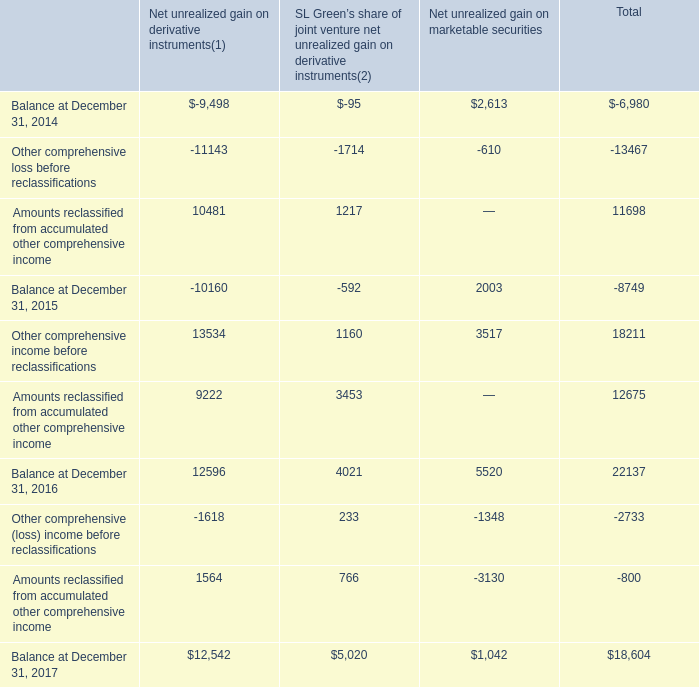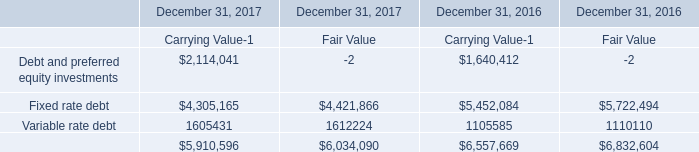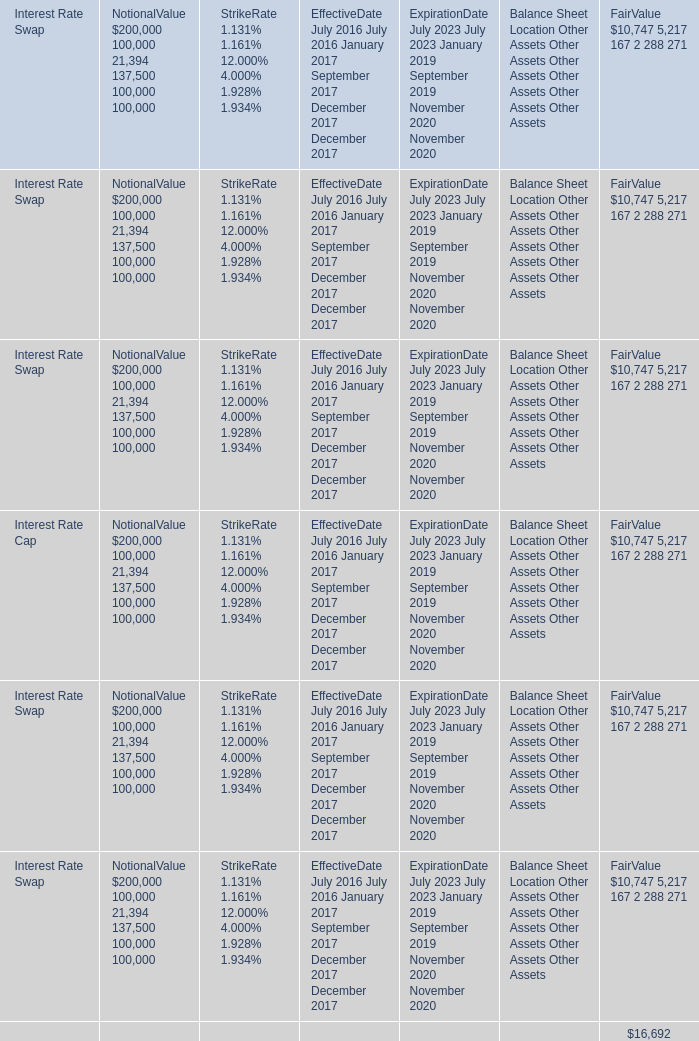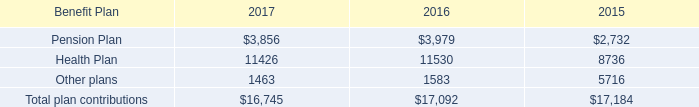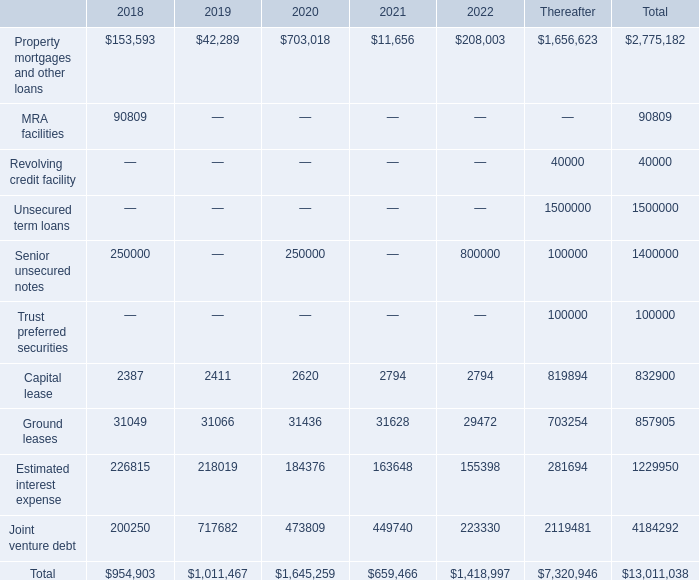What is the growing rate of Other comprehensive (loss) income before reclassifications in the year with the most Amounts reclassified from accumulated other comprehensive income? 
Computations: ((-2733 - 18211) / 18211)
Answer: -1.15007. 